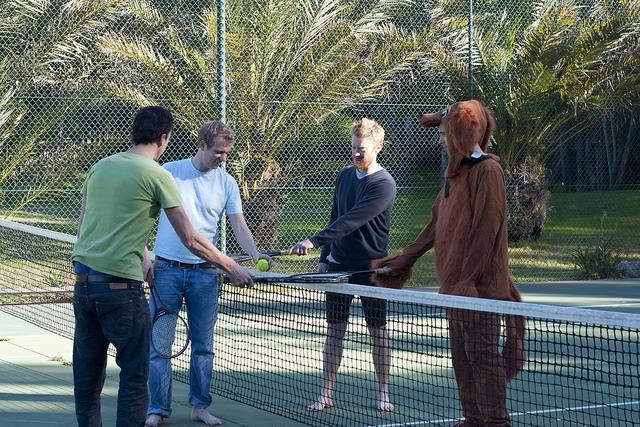Which one is inappropriately dressed?
Answer the question by selecting the correct answer among the 4 following choices and explain your choice with a short sentence. The answer should be formatted with the following format: `Answer: choice
Rationale: rationale.`
Options: Brown outfit, blue tshirt, green top, shorts. Answer: brown outfit.
Rationale: The people are standing on the tennis court, and one of the is dressed like a brown dog. 